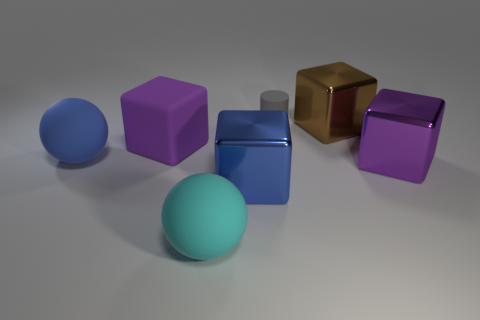Add 3 tiny rubber cylinders. How many objects exist? 10 Subtract all spheres. How many objects are left? 5 Add 7 metallic spheres. How many metallic spheres exist? 7 Subtract 1 blue spheres. How many objects are left? 6 Subtract all small cyan metallic objects. Subtract all brown blocks. How many objects are left? 6 Add 5 small gray things. How many small gray things are left? 6 